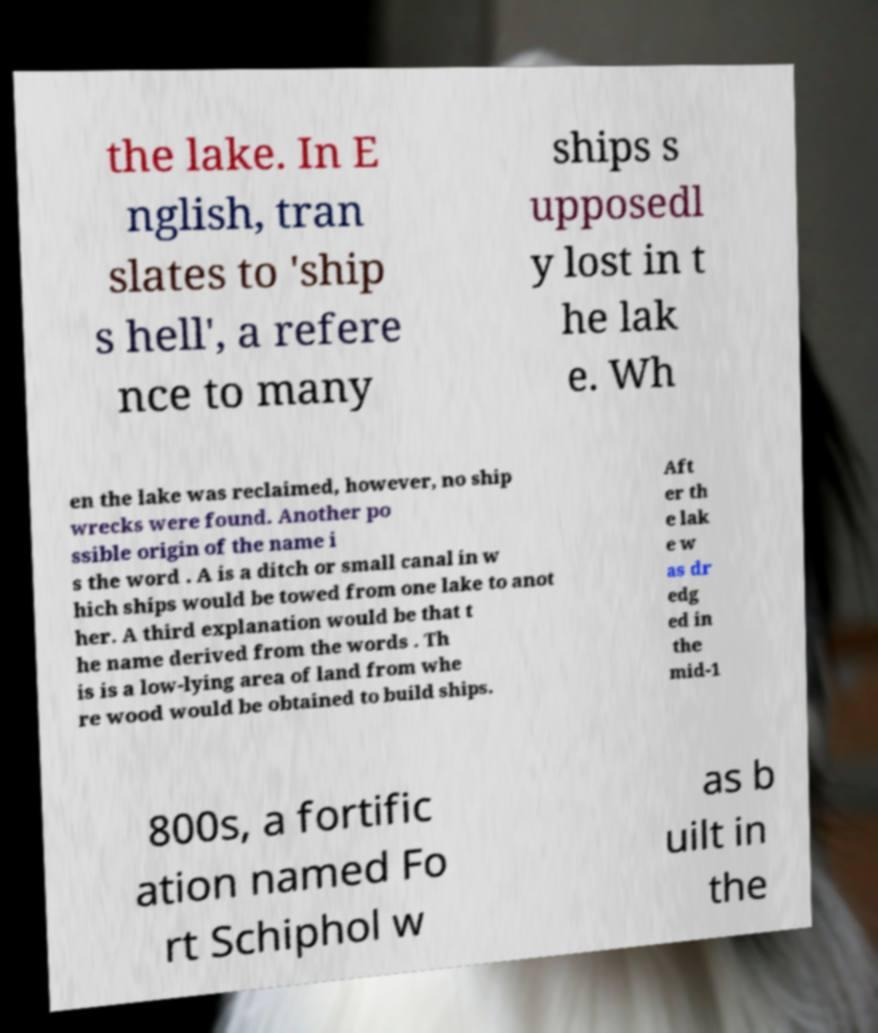Could you extract and type out the text from this image? the lake. In E nglish, tran slates to 'ship s hell', a refere nce to many ships s upposedl y lost in t he lak e. Wh en the lake was reclaimed, however, no ship wrecks were found. Another po ssible origin of the name i s the word . A is a ditch or small canal in w hich ships would be towed from one lake to anot her. A third explanation would be that t he name derived from the words . Th is is a low-lying area of land from whe re wood would be obtained to build ships. Aft er th e lak e w as dr edg ed in the mid-1 800s, a fortific ation named Fo rt Schiphol w as b uilt in the 